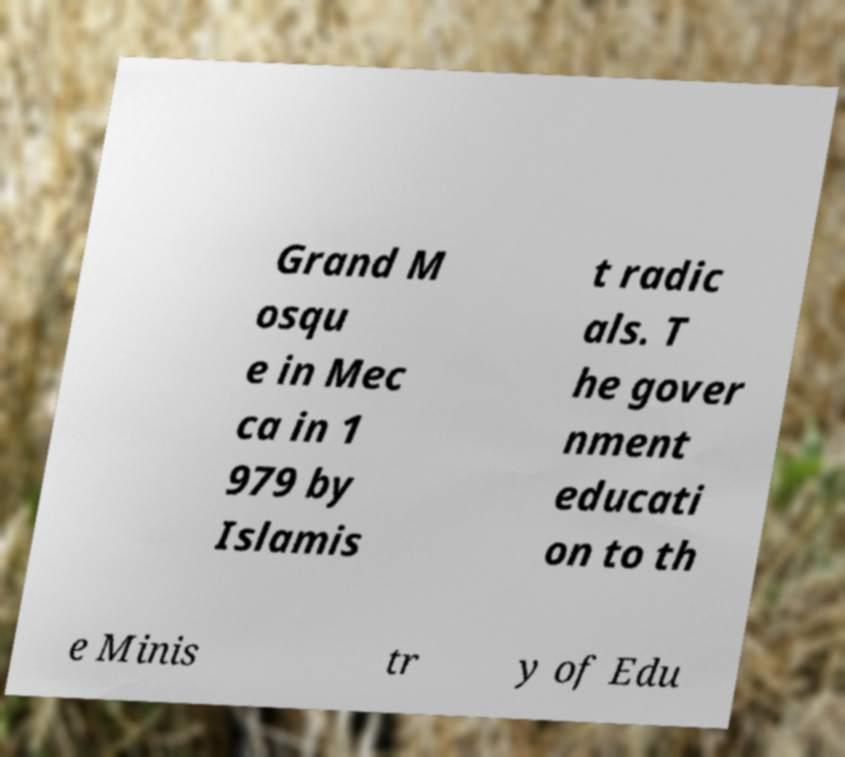Please identify and transcribe the text found in this image. Grand M osqu e in Mec ca in 1 979 by Islamis t radic als. T he gover nment educati on to th e Minis tr y of Edu 